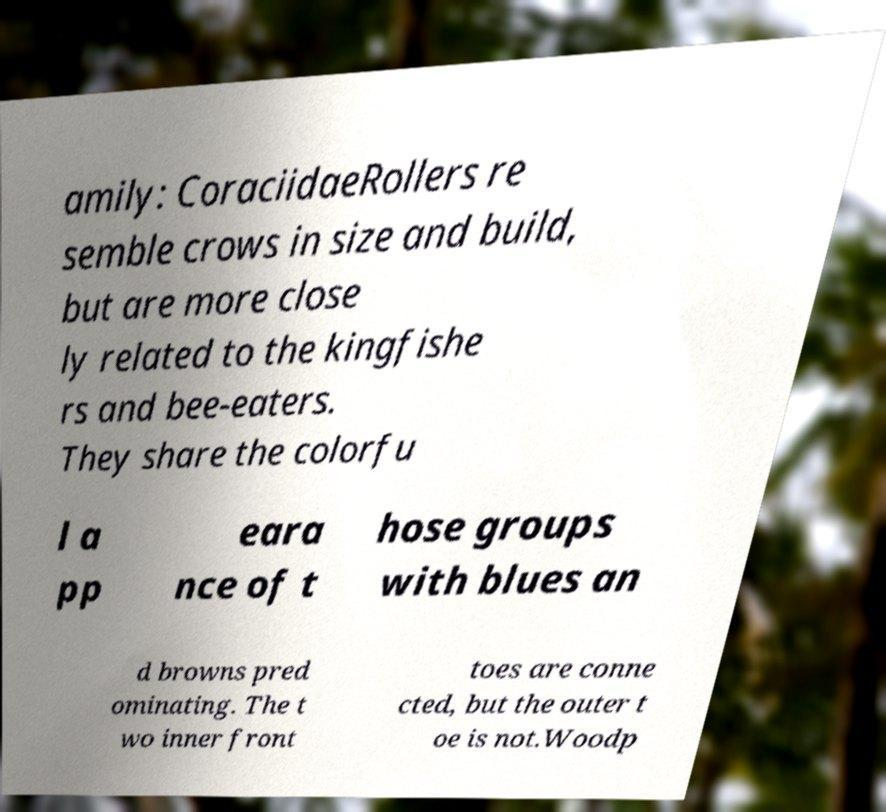Could you assist in decoding the text presented in this image and type it out clearly? amily: CoraciidaeRollers re semble crows in size and build, but are more close ly related to the kingfishe rs and bee-eaters. They share the colorfu l a pp eara nce of t hose groups with blues an d browns pred ominating. The t wo inner front toes are conne cted, but the outer t oe is not.Woodp 